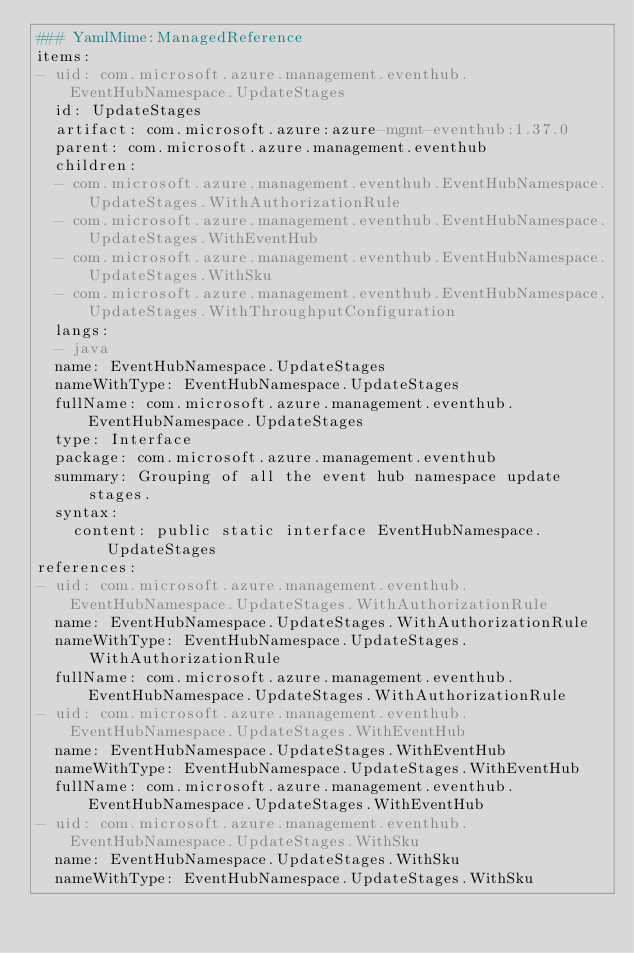Convert code to text. <code><loc_0><loc_0><loc_500><loc_500><_YAML_>### YamlMime:ManagedReference
items:
- uid: com.microsoft.azure.management.eventhub.EventHubNamespace.UpdateStages
  id: UpdateStages
  artifact: com.microsoft.azure:azure-mgmt-eventhub:1.37.0
  parent: com.microsoft.azure.management.eventhub
  children:
  - com.microsoft.azure.management.eventhub.EventHubNamespace.UpdateStages.WithAuthorizationRule
  - com.microsoft.azure.management.eventhub.EventHubNamespace.UpdateStages.WithEventHub
  - com.microsoft.azure.management.eventhub.EventHubNamespace.UpdateStages.WithSku
  - com.microsoft.azure.management.eventhub.EventHubNamespace.UpdateStages.WithThroughputConfiguration
  langs:
  - java
  name: EventHubNamespace.UpdateStages
  nameWithType: EventHubNamespace.UpdateStages
  fullName: com.microsoft.azure.management.eventhub.EventHubNamespace.UpdateStages
  type: Interface
  package: com.microsoft.azure.management.eventhub
  summary: Grouping of all the event hub namespace update stages.
  syntax:
    content: public static interface EventHubNamespace.UpdateStages
references:
- uid: com.microsoft.azure.management.eventhub.EventHubNamespace.UpdateStages.WithAuthorizationRule
  name: EventHubNamespace.UpdateStages.WithAuthorizationRule
  nameWithType: EventHubNamespace.UpdateStages.WithAuthorizationRule
  fullName: com.microsoft.azure.management.eventhub.EventHubNamespace.UpdateStages.WithAuthorizationRule
- uid: com.microsoft.azure.management.eventhub.EventHubNamespace.UpdateStages.WithEventHub
  name: EventHubNamespace.UpdateStages.WithEventHub
  nameWithType: EventHubNamespace.UpdateStages.WithEventHub
  fullName: com.microsoft.azure.management.eventhub.EventHubNamespace.UpdateStages.WithEventHub
- uid: com.microsoft.azure.management.eventhub.EventHubNamespace.UpdateStages.WithSku
  name: EventHubNamespace.UpdateStages.WithSku
  nameWithType: EventHubNamespace.UpdateStages.WithSku</code> 